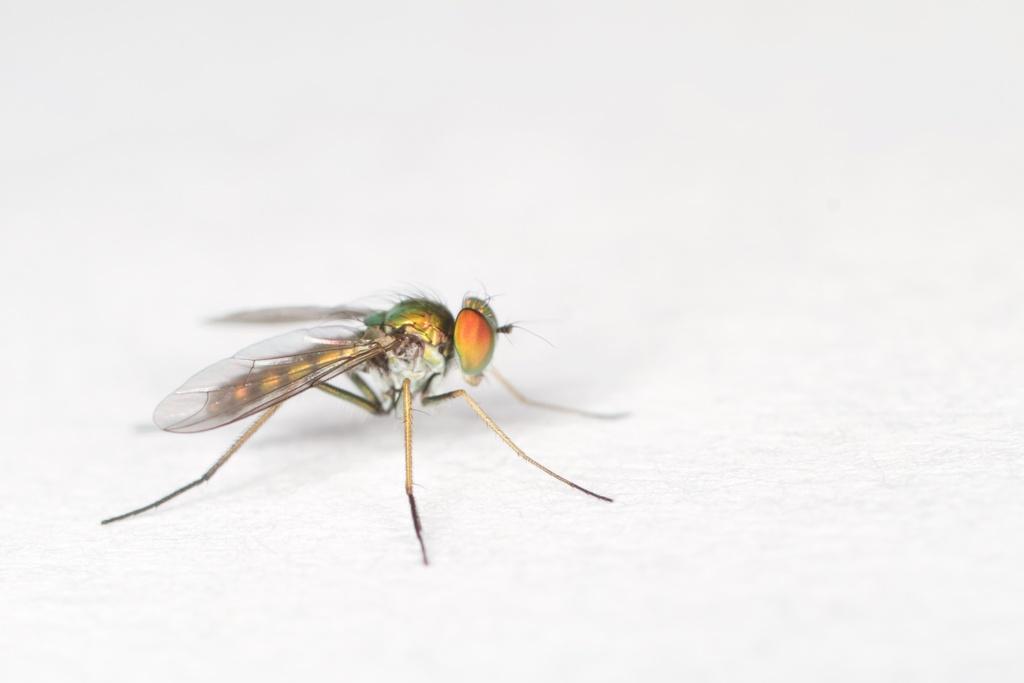Please provide a concise description of this image. In the foreground I can see a fly on a white color background. This image is taken may be in a room. 